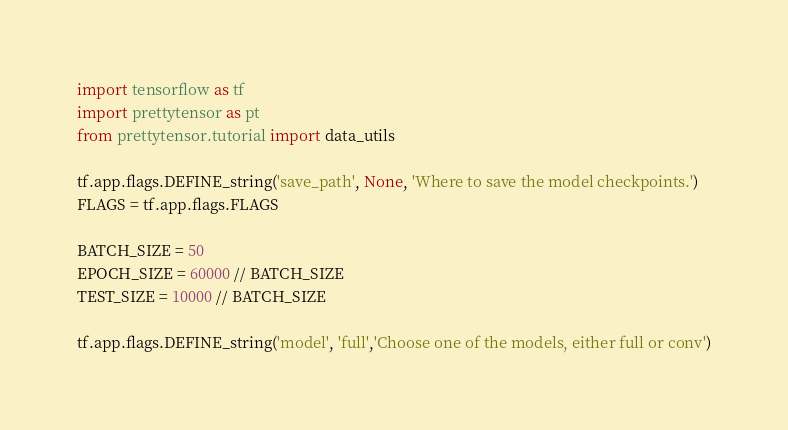<code> <loc_0><loc_0><loc_500><loc_500><_Python_>import tensorflow as tf
import prettytensor as pt
from prettytensor.tutorial import data_utils

tf.app.flags.DEFINE_string('save_path', None, 'Where to save the model checkpoints.')
FLAGS = tf.app.flags.FLAGS

BATCH_SIZE = 50
EPOCH_SIZE = 60000 // BATCH_SIZE
TEST_SIZE = 10000 // BATCH_SIZE

tf.app.flags.DEFINE_string('model', 'full','Choose one of the models, either full or conv')</code> 